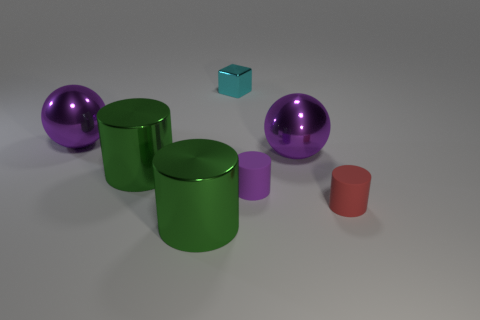There is another tiny thing that is the same shape as the red matte object; what color is it?
Your answer should be compact. Purple. Is there any other thing that has the same shape as the tiny cyan thing?
Keep it short and to the point. No. Are there the same number of shiny objects on the left side of the cube and purple things?
Ensure brevity in your answer.  Yes. There is a small purple matte cylinder; are there any big green objects on the right side of it?
Offer a terse response. No. What size is the purple shiny object on the right side of the purple ball left of the big green metallic thing behind the tiny red rubber thing?
Your answer should be very brief. Large. There is a big metallic thing that is in front of the small red matte cylinder; is its shape the same as the red rubber thing in front of the cyan metallic thing?
Provide a succinct answer. Yes. What number of cyan things have the same material as the small cube?
Provide a succinct answer. 0. What is the tiny cyan cube made of?
Offer a very short reply. Metal. The rubber thing on the right side of the ball that is to the right of the purple cylinder is what shape?
Ensure brevity in your answer.  Cylinder. There is a small shiny object that is behind the small red rubber object; what is its shape?
Offer a very short reply. Cube. 